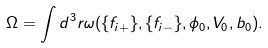<formula> <loc_0><loc_0><loc_500><loc_500>\Omega = \int d ^ { 3 } r \omega ( \{ f _ { i + } \} , \{ f _ { i - } \} , \phi _ { 0 } , V _ { 0 } , b _ { 0 } ) .</formula> 